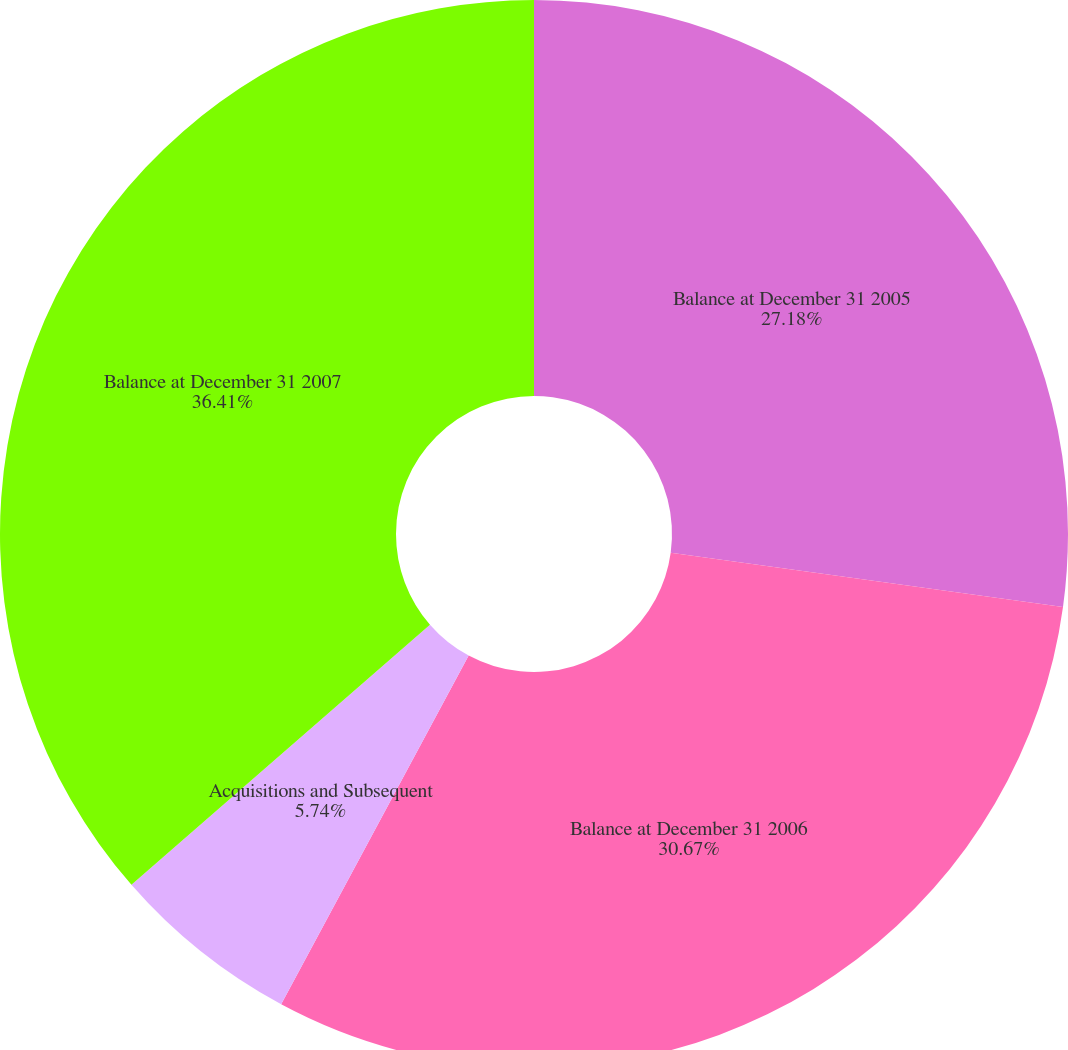Convert chart to OTSL. <chart><loc_0><loc_0><loc_500><loc_500><pie_chart><fcel>Balance at December 31 2005<fcel>Balance at December 31 2006<fcel>Acquisitions and Subsequent<fcel>Balance at December 31 2007<nl><fcel>27.18%<fcel>30.67%<fcel>5.74%<fcel>36.41%<nl></chart> 